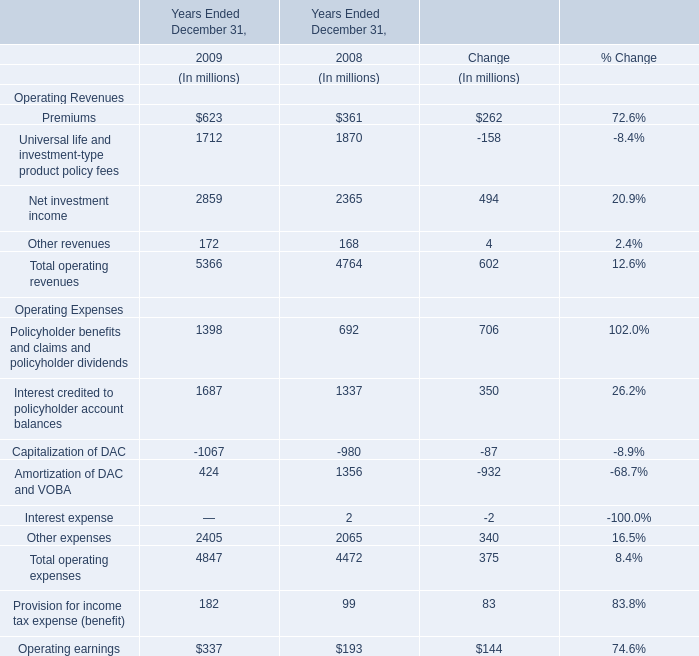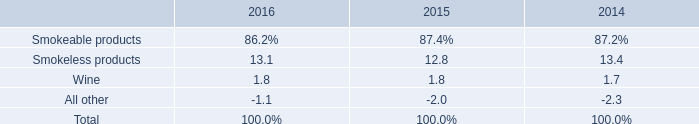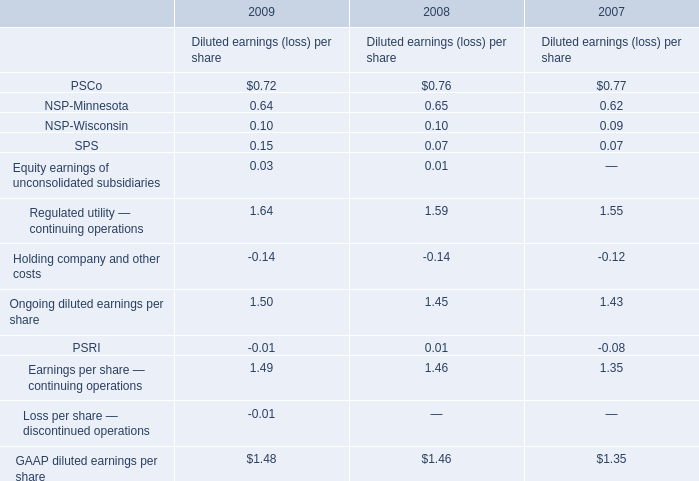Does the value of Premiums in 2008 greater than that in 2009？ 
Answer: no. what would total smokeless products shipment volume be in 2017 with the same growth rate as 2016 , in billions? 
Computations: (853.5 + 4.9%)
Answer: 853.549. 